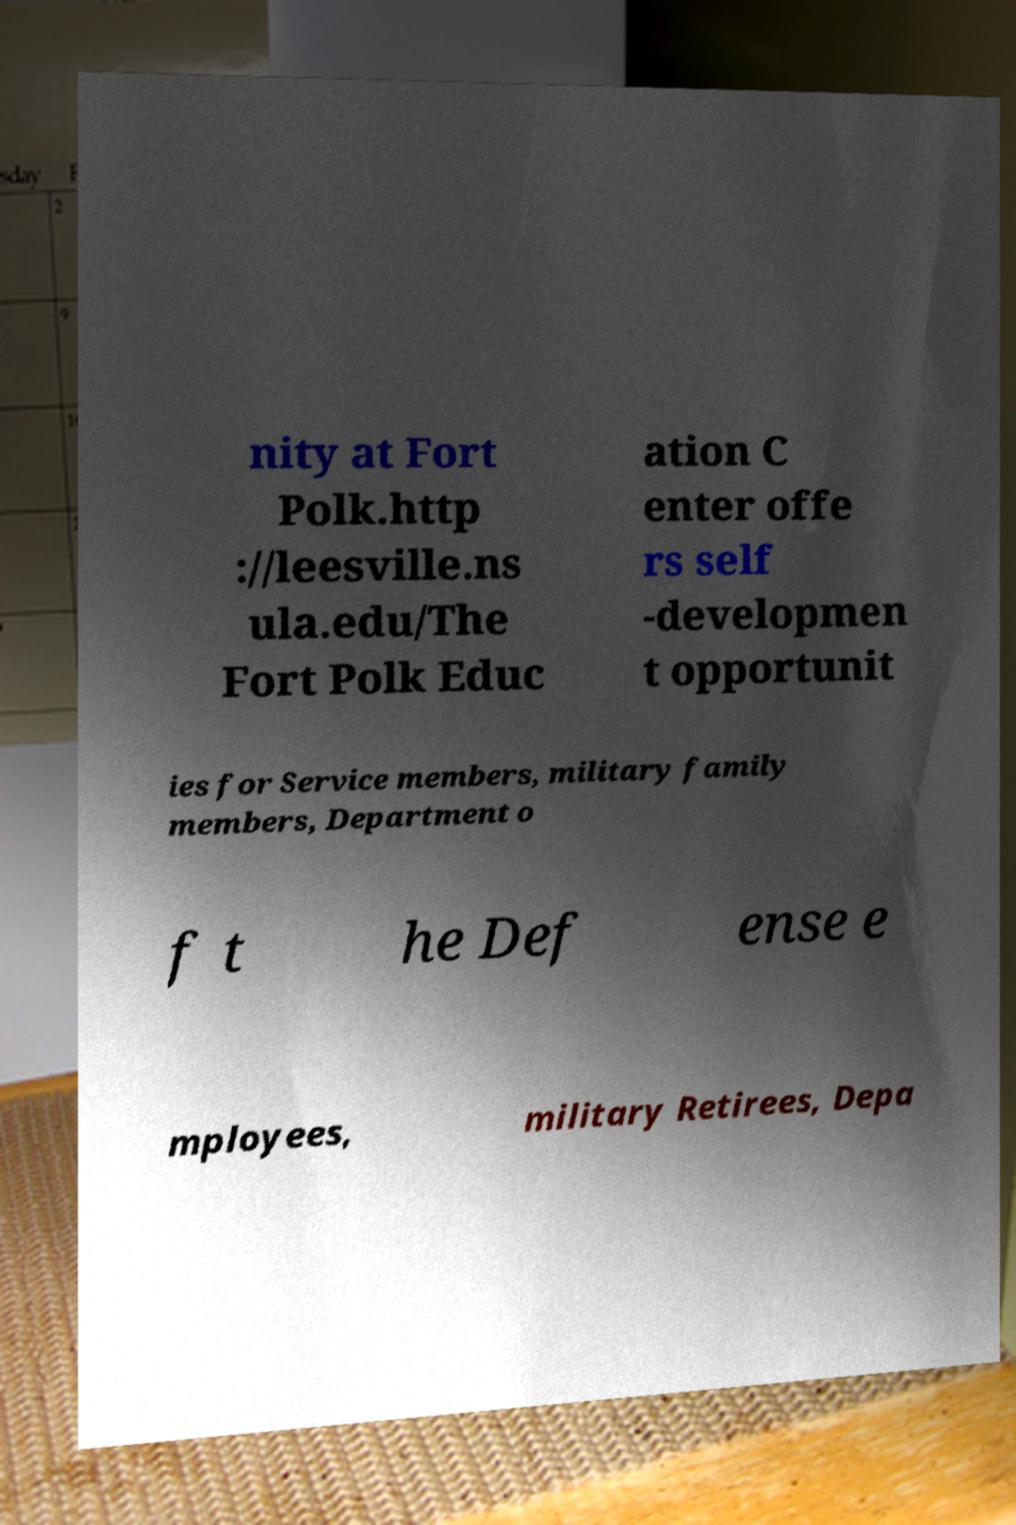I need the written content from this picture converted into text. Can you do that? nity at Fort Polk.http ://leesville.ns ula.edu/The Fort Polk Educ ation C enter offe rs self -developmen t opportunit ies for Service members, military family members, Department o f t he Def ense e mployees, military Retirees, Depa 